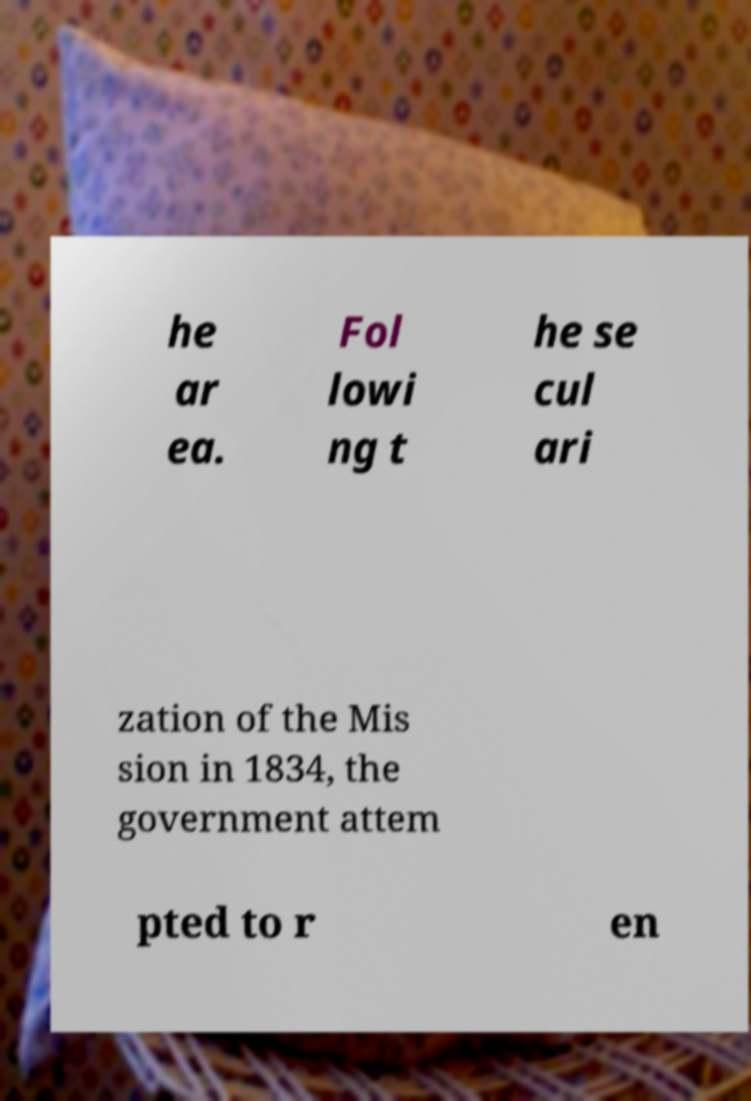I need the written content from this picture converted into text. Can you do that? he ar ea. Fol lowi ng t he se cul ari zation of the Mis sion in 1834, the government attem pted to r en 